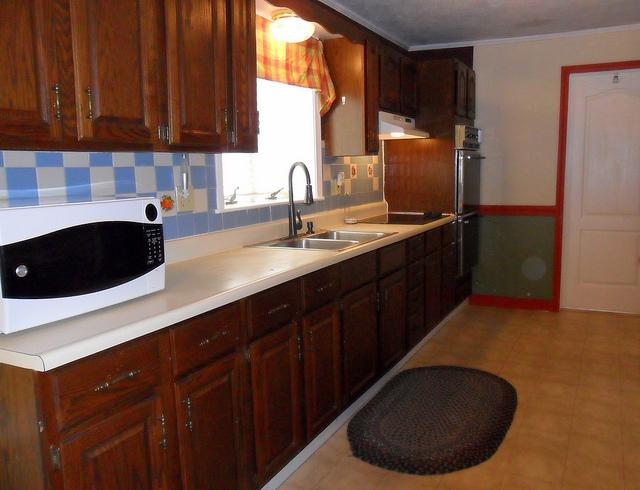What is the name for the pattern used on the window curtains? plaid 